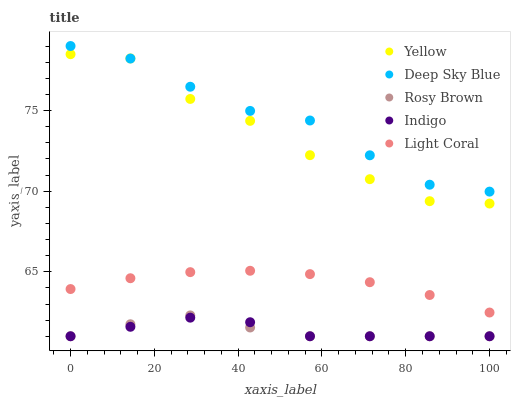Does Rosy Brown have the minimum area under the curve?
Answer yes or no. Yes. Does Deep Sky Blue have the maximum area under the curve?
Answer yes or no. Yes. Does Indigo have the minimum area under the curve?
Answer yes or no. No. Does Indigo have the maximum area under the curve?
Answer yes or no. No. Is Light Coral the smoothest?
Answer yes or no. Yes. Is Yellow the roughest?
Answer yes or no. Yes. Is Rosy Brown the smoothest?
Answer yes or no. No. Is Rosy Brown the roughest?
Answer yes or no. No. Does Rosy Brown have the lowest value?
Answer yes or no. Yes. Does Deep Sky Blue have the lowest value?
Answer yes or no. No. Does Deep Sky Blue have the highest value?
Answer yes or no. Yes. Does Rosy Brown have the highest value?
Answer yes or no. No. Is Light Coral less than Deep Sky Blue?
Answer yes or no. Yes. Is Yellow greater than Rosy Brown?
Answer yes or no. Yes. Does Rosy Brown intersect Indigo?
Answer yes or no. Yes. Is Rosy Brown less than Indigo?
Answer yes or no. No. Is Rosy Brown greater than Indigo?
Answer yes or no. No. Does Light Coral intersect Deep Sky Blue?
Answer yes or no. No. 